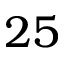Convert formula to latex. <formula><loc_0><loc_0><loc_500><loc_500>2 5</formula> 